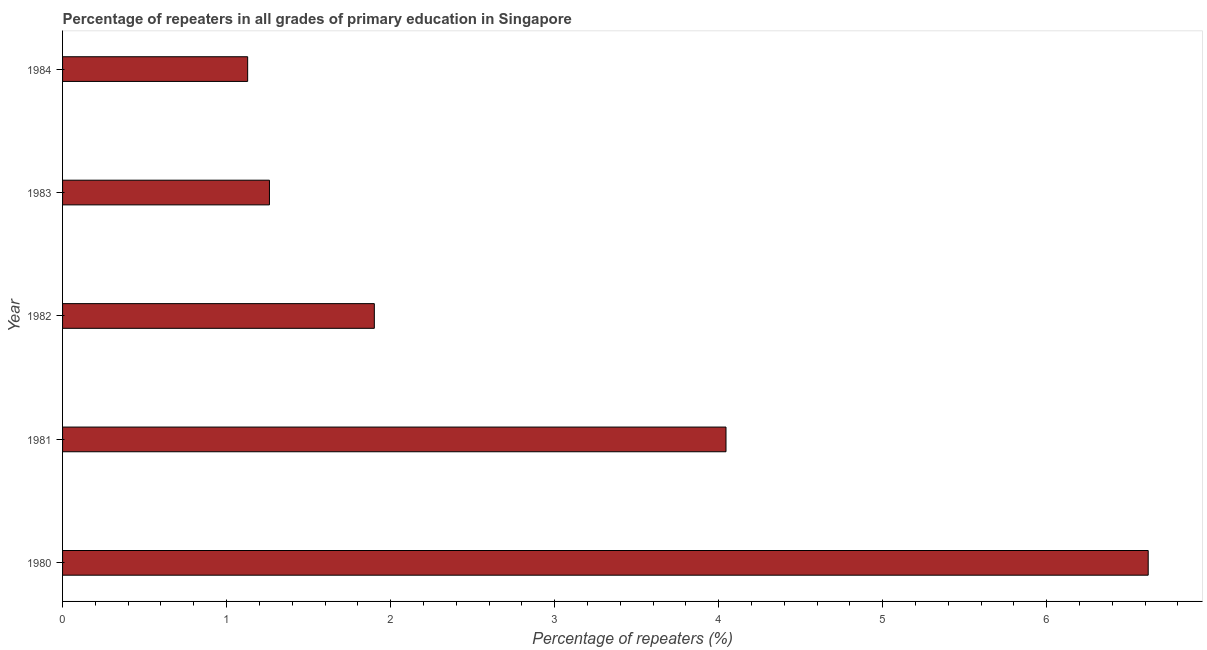Does the graph contain grids?
Ensure brevity in your answer.  No. What is the title of the graph?
Your answer should be compact. Percentage of repeaters in all grades of primary education in Singapore. What is the label or title of the X-axis?
Provide a short and direct response. Percentage of repeaters (%). What is the label or title of the Y-axis?
Keep it short and to the point. Year. What is the percentage of repeaters in primary education in 1984?
Ensure brevity in your answer.  1.13. Across all years, what is the maximum percentage of repeaters in primary education?
Ensure brevity in your answer.  6.62. Across all years, what is the minimum percentage of repeaters in primary education?
Give a very brief answer. 1.13. What is the sum of the percentage of repeaters in primary education?
Keep it short and to the point. 14.95. What is the difference between the percentage of repeaters in primary education in 1981 and 1983?
Provide a succinct answer. 2.78. What is the average percentage of repeaters in primary education per year?
Keep it short and to the point. 2.99. What is the median percentage of repeaters in primary education?
Your answer should be compact. 1.9. In how many years, is the percentage of repeaters in primary education greater than 3 %?
Keep it short and to the point. 2. Do a majority of the years between 1983 and 1980 (inclusive) have percentage of repeaters in primary education greater than 0.8 %?
Your answer should be compact. Yes. What is the ratio of the percentage of repeaters in primary education in 1982 to that in 1984?
Provide a succinct answer. 1.68. What is the difference between the highest and the second highest percentage of repeaters in primary education?
Offer a very short reply. 2.57. Is the sum of the percentage of repeaters in primary education in 1980 and 1982 greater than the maximum percentage of repeaters in primary education across all years?
Your answer should be compact. Yes. What is the difference between the highest and the lowest percentage of repeaters in primary education?
Your answer should be very brief. 5.49. In how many years, is the percentage of repeaters in primary education greater than the average percentage of repeaters in primary education taken over all years?
Offer a very short reply. 2. How many bars are there?
Provide a short and direct response. 5. Are all the bars in the graph horizontal?
Offer a terse response. Yes. What is the difference between two consecutive major ticks on the X-axis?
Ensure brevity in your answer.  1. Are the values on the major ticks of X-axis written in scientific E-notation?
Provide a succinct answer. No. What is the Percentage of repeaters (%) in 1980?
Offer a terse response. 6.62. What is the Percentage of repeaters (%) in 1981?
Offer a terse response. 4.04. What is the Percentage of repeaters (%) of 1982?
Your answer should be very brief. 1.9. What is the Percentage of repeaters (%) in 1983?
Make the answer very short. 1.26. What is the Percentage of repeaters (%) of 1984?
Offer a very short reply. 1.13. What is the difference between the Percentage of repeaters (%) in 1980 and 1981?
Provide a succinct answer. 2.57. What is the difference between the Percentage of repeaters (%) in 1980 and 1982?
Provide a short and direct response. 4.72. What is the difference between the Percentage of repeaters (%) in 1980 and 1983?
Your response must be concise. 5.36. What is the difference between the Percentage of repeaters (%) in 1980 and 1984?
Your response must be concise. 5.49. What is the difference between the Percentage of repeaters (%) in 1981 and 1982?
Provide a succinct answer. 2.14. What is the difference between the Percentage of repeaters (%) in 1981 and 1983?
Ensure brevity in your answer.  2.78. What is the difference between the Percentage of repeaters (%) in 1981 and 1984?
Your answer should be very brief. 2.92. What is the difference between the Percentage of repeaters (%) in 1982 and 1983?
Offer a very short reply. 0.64. What is the difference between the Percentage of repeaters (%) in 1982 and 1984?
Ensure brevity in your answer.  0.77. What is the difference between the Percentage of repeaters (%) in 1983 and 1984?
Offer a very short reply. 0.13. What is the ratio of the Percentage of repeaters (%) in 1980 to that in 1981?
Your response must be concise. 1.64. What is the ratio of the Percentage of repeaters (%) in 1980 to that in 1982?
Provide a short and direct response. 3.48. What is the ratio of the Percentage of repeaters (%) in 1980 to that in 1983?
Keep it short and to the point. 5.25. What is the ratio of the Percentage of repeaters (%) in 1980 to that in 1984?
Provide a succinct answer. 5.87. What is the ratio of the Percentage of repeaters (%) in 1981 to that in 1982?
Give a very brief answer. 2.13. What is the ratio of the Percentage of repeaters (%) in 1981 to that in 1983?
Ensure brevity in your answer.  3.21. What is the ratio of the Percentage of repeaters (%) in 1981 to that in 1984?
Make the answer very short. 3.58. What is the ratio of the Percentage of repeaters (%) in 1982 to that in 1983?
Provide a succinct answer. 1.51. What is the ratio of the Percentage of repeaters (%) in 1982 to that in 1984?
Your answer should be compact. 1.68. What is the ratio of the Percentage of repeaters (%) in 1983 to that in 1984?
Offer a very short reply. 1.12. 